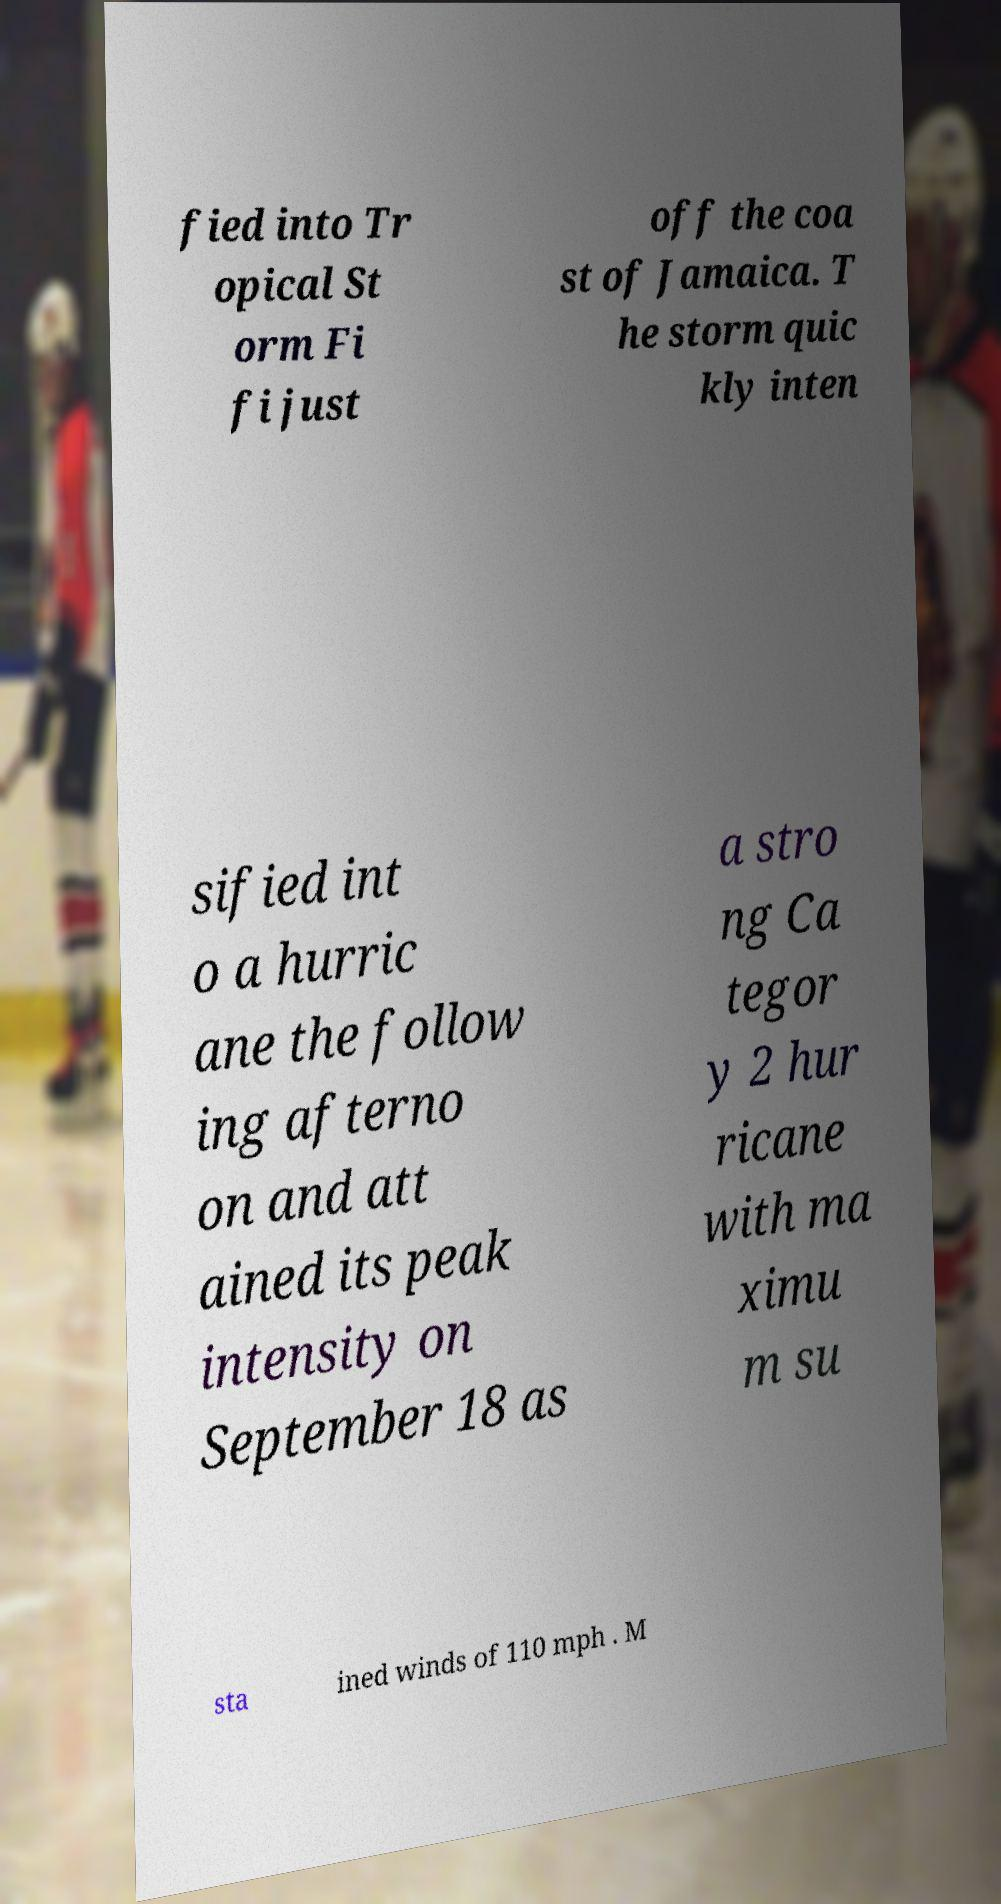Could you assist in decoding the text presented in this image and type it out clearly? fied into Tr opical St orm Fi fi just off the coa st of Jamaica. T he storm quic kly inten sified int o a hurric ane the follow ing afterno on and att ained its peak intensity on September 18 as a stro ng Ca tegor y 2 hur ricane with ma ximu m su sta ined winds of 110 mph . M 